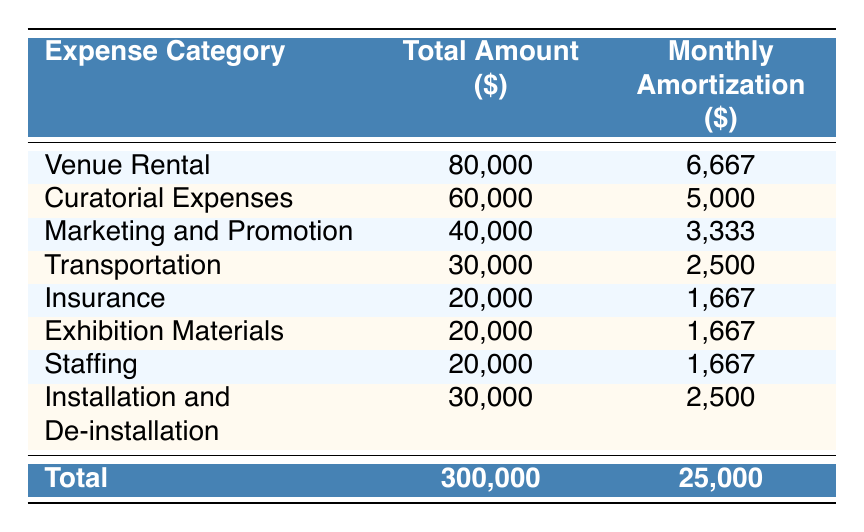What is the total amount spent on the exhibition? The total amount is listed at the bottom of the table as a total in the "Total Amount ($)" column, which reads 300,000 dollars.
Answer: 300,000 How much is the monthly amortization of the Curatorial Expenses? The "Monthly Amortization ($)" column for Curatorial Expenses shows a value of 5,000 dollars.
Answer: 5,000 Is the combined total for Insurance and Exhibition Materials greater than the monthly amortization for Marketing and Promotion? The total for Insurance (20,000) and Exhibition Materials (20,000) is 40,000. The monthly amortization for Marketing and Promotion is 3,333. Since 40,000 is greater than 3,333, this statement is true.
Answer: Yes What is the average monthly amortization across all expense categories? To find the average, sum the monthly amortization amounts: 6,667 + 5,000 + 3,333 + 2,500 + 1,667 + 1,667 + 1,667 + 2,500 = 25,000. There are 8 categories, so the average is 25,000 / 8 = 3,125.
Answer: 3,125 How much more is allocated to Venue Rental compared to Staffing? The amount for Venue Rental is 80,000 and for Staffing it is 20,000. The difference is 80,000 - 20,000 = 60,000.
Answer: 60,000 Is the total for Transportation less than that for Marketing and Promotion? The table shows that Transportation is 30,000 and Marketing and Promotion is 40,000. Since 30,000 is less than 40,000, this statement is true.
Answer: Yes What total is spent on Insurance, Exhibition Materials, and Staffing combined? To find the total, add the amounts: Insurance (20,000) + Exhibition Materials (20,000) + Staffing (20,000) = 60,000.
Answer: 60,000 Which expense category has the highest monthly amortization, and what is that amount? By comparing the monthly amortization values, Venue Rental has the highest value at 6,667 dollars.
Answer: Venue Rental, 6,667 How much is spent on Marketing and Promotion compared to Installation and De-installation in total? The amount for Marketing and Promotion is 40,000, and for Installation and De-installation, it is 30,000. Their combined total is 40,000 + 30,000 = 70,000.
Answer: 70,000 